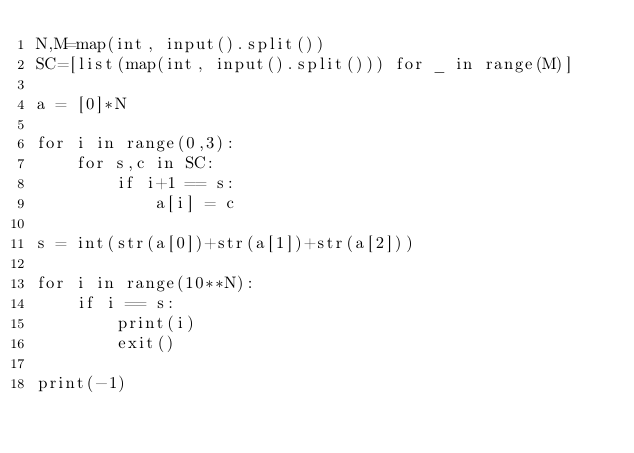<code> <loc_0><loc_0><loc_500><loc_500><_Python_>N,M=map(int, input().split())
SC=[list(map(int, input().split())) for _ in range(M)]

a = [0]*N

for i in range(0,3):
    for s,c in SC:
        if i+1 == s:
            a[i] = c

s = int(str(a[0])+str(a[1])+str(a[2]))

for i in range(10**N):
    if i == s:
        print(i)
        exit()

print(-1)</code> 